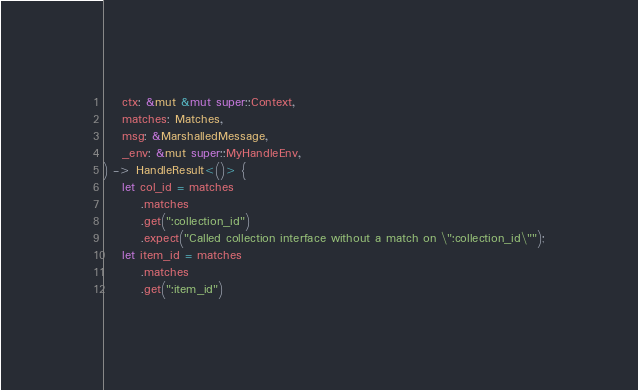Convert code to text. <code><loc_0><loc_0><loc_500><loc_500><_Rust_>    ctx: &mut &mut super::Context,
    matches: Matches,
    msg: &MarshalledMessage,
    _env: &mut super::MyHandleEnv,
) -> HandleResult<()> {
    let col_id = matches
        .matches
        .get(":collection_id")
        .expect("Called collection interface without a match on \":collection_id\"");
    let item_id = matches
        .matches
        .get(":item_id")</code> 